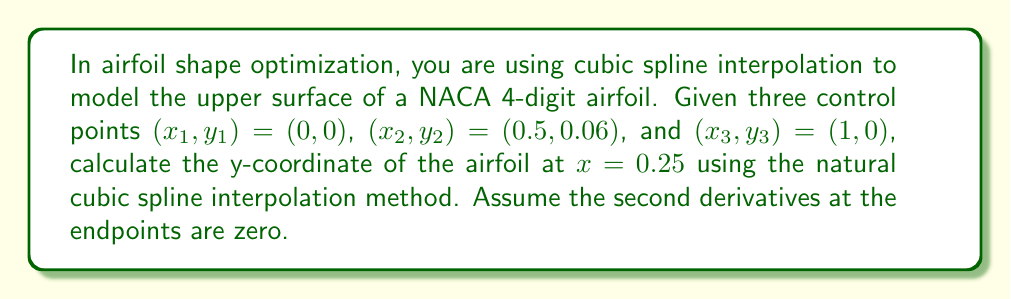Give your solution to this math problem. Let's approach this step-by-step:

1) For natural cubic splines, we have $S''(x_1) = S''(x_3) = 0$.

2) We need to solve the following system of equations:
   $$\begin{bmatrix}
   2(h_1 + h_2) & h_2 & 0 \\
   h_2 & 2(h_2 + h_3) & h_3 \\
   0 & h_3 & 2(h_3 + h_4)
   \end{bmatrix}
   \begin{bmatrix}
   S''(x_2) \\
   S''(x_3) \\
   S''(x_4)
   \end{bmatrix} = 
   6\begin{bmatrix}
   \frac{y_3 - y_2}{h_2} - \frac{y_2 - y_1}{h_1} \\
   \frac{y_4 - y_3}{h_3} - \frac{y_3 - y_2}{h_2} \\
   \frac{y_5 - y_4}{h_4} - \frac{y_4 - y_3}{h_3}
   \end{bmatrix}$$

   Where $h_i = x_{i+1} - x_i$

3) In our case, we only have 3 points, so this simplifies to:
   $$2(h_1 + h_2) \cdot S''(x_2) = 6(\frac{y_3 - y_2}{h_2} - \frac{y_2 - y_1}{h_1})$$

4) Calculating $h_1$ and $h_2$:
   $h_1 = 0.5 - 0 = 0.5$
   $h_2 = 1 - 0.5 = 0.5$

5) Substituting into the equation:
   $$2(0.5 + 0.5) \cdot S''(x_2) = 6(\frac{0 - 0.06}{0.5} - \frac{0.06 - 0}{0.5})$$
   $$2 \cdot S''(x_2) = 6(-0.12 - 0.12) = -1.44$$
   $$S''(x_2) = -0.72$$

6) Now we can use the cubic spline formula for the interval $[x_1, x_2]$:
   $$S(x) = \frac{S''(x_1)}{6h_1}(x_2 - x)^3 + \frac{S''(x_2)}{6h_1}(x - x_1)^3 + (\frac{y_2}{h_1} - \frac{h_1S''(x_2)}{6})(x - x_1) + (\frac{y_1}{h_1} - \frac{h_1S''(x_1)}{6})(x_2 - x)$$

7) Substituting known values:
   $$S(x) = 0 + \frac{-0.72}{6 \cdot 0.5}(x - 0)^3 + (\frac{0.06}{0.5} - \frac{0.5 \cdot -0.72}{6})(x - 0) + (\frac{0}{0.5} - 0)(0.5 - x)$$
   $$S(x) = -0.24(x - 0)^3 + (0.12 + 0.06)(x - 0)$$
   $$S(x) = -0.24x^3 + 0.18x$$

8) To find y at x = 0.25:
   $$S(0.25) = -0.24(0.25)^3 + 0.18(0.25) = -0.00375 + 0.045 = 0.04125$$

Therefore, at x = 0.25, the y-coordinate is approximately 0.04125.
Answer: 0.04125 